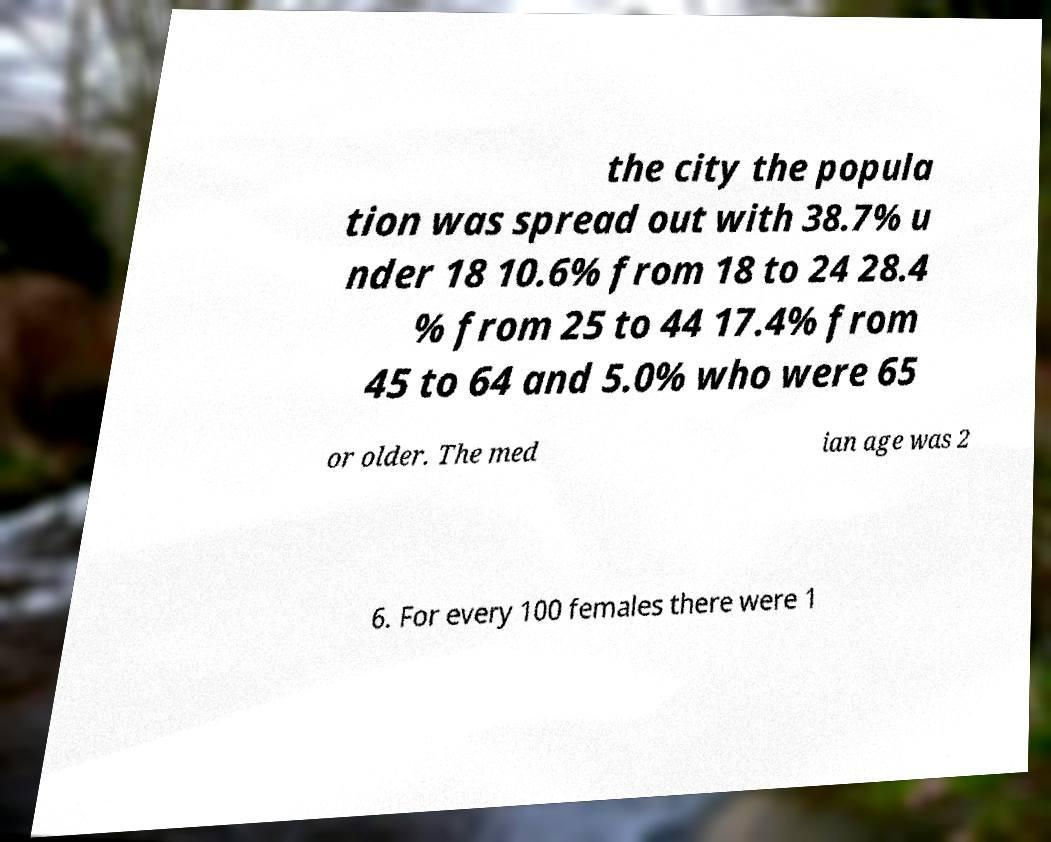Please identify and transcribe the text found in this image. the city the popula tion was spread out with 38.7% u nder 18 10.6% from 18 to 24 28.4 % from 25 to 44 17.4% from 45 to 64 and 5.0% who were 65 or older. The med ian age was 2 6. For every 100 females there were 1 